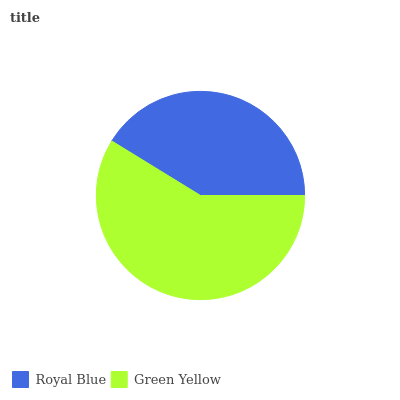Is Royal Blue the minimum?
Answer yes or no. Yes. Is Green Yellow the maximum?
Answer yes or no. Yes. Is Green Yellow the minimum?
Answer yes or no. No. Is Green Yellow greater than Royal Blue?
Answer yes or no. Yes. Is Royal Blue less than Green Yellow?
Answer yes or no. Yes. Is Royal Blue greater than Green Yellow?
Answer yes or no. No. Is Green Yellow less than Royal Blue?
Answer yes or no. No. Is Green Yellow the high median?
Answer yes or no. Yes. Is Royal Blue the low median?
Answer yes or no. Yes. Is Royal Blue the high median?
Answer yes or no. No. Is Green Yellow the low median?
Answer yes or no. No. 